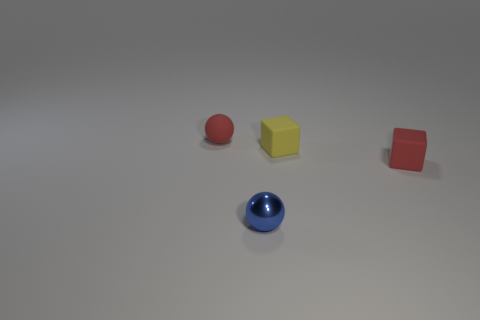Considering the lighting and shadows, what can be inferred about the light source in this image? The shadows of the objects are diffused and short, which may indicate a light source that is relatively large and not too far above the scene, possibly an overhead diffused lighting system, casting soft shadows that imply an indoor setting. 